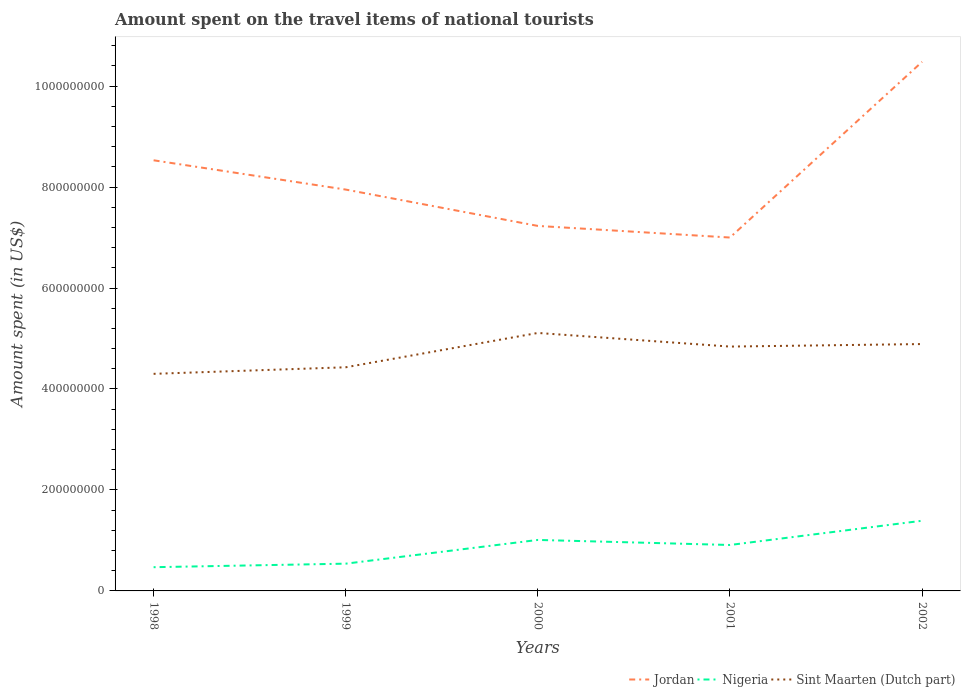Across all years, what is the maximum amount spent on the travel items of national tourists in Nigeria?
Your answer should be very brief. 4.70e+07. In which year was the amount spent on the travel items of national tourists in Sint Maarten (Dutch part) maximum?
Provide a succinct answer. 1998. What is the total amount spent on the travel items of national tourists in Jordan in the graph?
Your answer should be very brief. -2.53e+08. What is the difference between the highest and the second highest amount spent on the travel items of national tourists in Sint Maarten (Dutch part)?
Keep it short and to the point. 8.10e+07. How many lines are there?
Ensure brevity in your answer.  3. Are the values on the major ticks of Y-axis written in scientific E-notation?
Give a very brief answer. No. Does the graph contain grids?
Provide a succinct answer. No. Where does the legend appear in the graph?
Your answer should be compact. Bottom right. How many legend labels are there?
Your answer should be very brief. 3. How are the legend labels stacked?
Provide a succinct answer. Horizontal. What is the title of the graph?
Keep it short and to the point. Amount spent on the travel items of national tourists. Does "Central Europe" appear as one of the legend labels in the graph?
Keep it short and to the point. No. What is the label or title of the Y-axis?
Keep it short and to the point. Amount spent (in US$). What is the Amount spent (in US$) in Jordan in 1998?
Your answer should be very brief. 8.53e+08. What is the Amount spent (in US$) of Nigeria in 1998?
Provide a succinct answer. 4.70e+07. What is the Amount spent (in US$) of Sint Maarten (Dutch part) in 1998?
Provide a succinct answer. 4.30e+08. What is the Amount spent (in US$) of Jordan in 1999?
Provide a succinct answer. 7.95e+08. What is the Amount spent (in US$) in Nigeria in 1999?
Your response must be concise. 5.40e+07. What is the Amount spent (in US$) of Sint Maarten (Dutch part) in 1999?
Give a very brief answer. 4.43e+08. What is the Amount spent (in US$) of Jordan in 2000?
Make the answer very short. 7.23e+08. What is the Amount spent (in US$) of Nigeria in 2000?
Your answer should be compact. 1.01e+08. What is the Amount spent (in US$) of Sint Maarten (Dutch part) in 2000?
Make the answer very short. 5.11e+08. What is the Amount spent (in US$) in Jordan in 2001?
Provide a succinct answer. 7.00e+08. What is the Amount spent (in US$) of Nigeria in 2001?
Make the answer very short. 9.10e+07. What is the Amount spent (in US$) in Sint Maarten (Dutch part) in 2001?
Provide a succinct answer. 4.84e+08. What is the Amount spent (in US$) of Jordan in 2002?
Offer a terse response. 1.05e+09. What is the Amount spent (in US$) in Nigeria in 2002?
Offer a terse response. 1.39e+08. What is the Amount spent (in US$) of Sint Maarten (Dutch part) in 2002?
Keep it short and to the point. 4.89e+08. Across all years, what is the maximum Amount spent (in US$) in Jordan?
Make the answer very short. 1.05e+09. Across all years, what is the maximum Amount spent (in US$) in Nigeria?
Offer a terse response. 1.39e+08. Across all years, what is the maximum Amount spent (in US$) of Sint Maarten (Dutch part)?
Your answer should be compact. 5.11e+08. Across all years, what is the minimum Amount spent (in US$) in Jordan?
Ensure brevity in your answer.  7.00e+08. Across all years, what is the minimum Amount spent (in US$) of Nigeria?
Make the answer very short. 4.70e+07. Across all years, what is the minimum Amount spent (in US$) in Sint Maarten (Dutch part)?
Your answer should be very brief. 4.30e+08. What is the total Amount spent (in US$) in Jordan in the graph?
Provide a short and direct response. 4.12e+09. What is the total Amount spent (in US$) of Nigeria in the graph?
Offer a terse response. 4.32e+08. What is the total Amount spent (in US$) of Sint Maarten (Dutch part) in the graph?
Offer a very short reply. 2.36e+09. What is the difference between the Amount spent (in US$) of Jordan in 1998 and that in 1999?
Your response must be concise. 5.80e+07. What is the difference between the Amount spent (in US$) of Nigeria in 1998 and that in 1999?
Your answer should be very brief. -7.00e+06. What is the difference between the Amount spent (in US$) in Sint Maarten (Dutch part) in 1998 and that in 1999?
Provide a succinct answer. -1.30e+07. What is the difference between the Amount spent (in US$) of Jordan in 1998 and that in 2000?
Give a very brief answer. 1.30e+08. What is the difference between the Amount spent (in US$) in Nigeria in 1998 and that in 2000?
Your response must be concise. -5.40e+07. What is the difference between the Amount spent (in US$) in Sint Maarten (Dutch part) in 1998 and that in 2000?
Your answer should be very brief. -8.10e+07. What is the difference between the Amount spent (in US$) of Jordan in 1998 and that in 2001?
Make the answer very short. 1.53e+08. What is the difference between the Amount spent (in US$) of Nigeria in 1998 and that in 2001?
Provide a short and direct response. -4.40e+07. What is the difference between the Amount spent (in US$) of Sint Maarten (Dutch part) in 1998 and that in 2001?
Provide a succinct answer. -5.40e+07. What is the difference between the Amount spent (in US$) in Jordan in 1998 and that in 2002?
Offer a very short reply. -1.95e+08. What is the difference between the Amount spent (in US$) in Nigeria in 1998 and that in 2002?
Offer a terse response. -9.20e+07. What is the difference between the Amount spent (in US$) in Sint Maarten (Dutch part) in 1998 and that in 2002?
Provide a succinct answer. -5.90e+07. What is the difference between the Amount spent (in US$) in Jordan in 1999 and that in 2000?
Give a very brief answer. 7.20e+07. What is the difference between the Amount spent (in US$) in Nigeria in 1999 and that in 2000?
Keep it short and to the point. -4.70e+07. What is the difference between the Amount spent (in US$) of Sint Maarten (Dutch part) in 1999 and that in 2000?
Give a very brief answer. -6.80e+07. What is the difference between the Amount spent (in US$) in Jordan in 1999 and that in 2001?
Give a very brief answer. 9.50e+07. What is the difference between the Amount spent (in US$) of Nigeria in 1999 and that in 2001?
Give a very brief answer. -3.70e+07. What is the difference between the Amount spent (in US$) of Sint Maarten (Dutch part) in 1999 and that in 2001?
Keep it short and to the point. -4.10e+07. What is the difference between the Amount spent (in US$) in Jordan in 1999 and that in 2002?
Give a very brief answer. -2.53e+08. What is the difference between the Amount spent (in US$) in Nigeria in 1999 and that in 2002?
Make the answer very short. -8.50e+07. What is the difference between the Amount spent (in US$) in Sint Maarten (Dutch part) in 1999 and that in 2002?
Ensure brevity in your answer.  -4.60e+07. What is the difference between the Amount spent (in US$) in Jordan in 2000 and that in 2001?
Keep it short and to the point. 2.30e+07. What is the difference between the Amount spent (in US$) in Nigeria in 2000 and that in 2001?
Your answer should be compact. 1.00e+07. What is the difference between the Amount spent (in US$) of Sint Maarten (Dutch part) in 2000 and that in 2001?
Provide a succinct answer. 2.70e+07. What is the difference between the Amount spent (in US$) in Jordan in 2000 and that in 2002?
Offer a very short reply. -3.25e+08. What is the difference between the Amount spent (in US$) of Nigeria in 2000 and that in 2002?
Your answer should be compact. -3.80e+07. What is the difference between the Amount spent (in US$) of Sint Maarten (Dutch part) in 2000 and that in 2002?
Provide a short and direct response. 2.20e+07. What is the difference between the Amount spent (in US$) in Jordan in 2001 and that in 2002?
Your answer should be compact. -3.48e+08. What is the difference between the Amount spent (in US$) of Nigeria in 2001 and that in 2002?
Ensure brevity in your answer.  -4.80e+07. What is the difference between the Amount spent (in US$) of Sint Maarten (Dutch part) in 2001 and that in 2002?
Offer a terse response. -5.00e+06. What is the difference between the Amount spent (in US$) of Jordan in 1998 and the Amount spent (in US$) of Nigeria in 1999?
Your response must be concise. 7.99e+08. What is the difference between the Amount spent (in US$) in Jordan in 1998 and the Amount spent (in US$) in Sint Maarten (Dutch part) in 1999?
Provide a short and direct response. 4.10e+08. What is the difference between the Amount spent (in US$) of Nigeria in 1998 and the Amount spent (in US$) of Sint Maarten (Dutch part) in 1999?
Your answer should be compact. -3.96e+08. What is the difference between the Amount spent (in US$) of Jordan in 1998 and the Amount spent (in US$) of Nigeria in 2000?
Keep it short and to the point. 7.52e+08. What is the difference between the Amount spent (in US$) in Jordan in 1998 and the Amount spent (in US$) in Sint Maarten (Dutch part) in 2000?
Your response must be concise. 3.42e+08. What is the difference between the Amount spent (in US$) of Nigeria in 1998 and the Amount spent (in US$) of Sint Maarten (Dutch part) in 2000?
Keep it short and to the point. -4.64e+08. What is the difference between the Amount spent (in US$) in Jordan in 1998 and the Amount spent (in US$) in Nigeria in 2001?
Keep it short and to the point. 7.62e+08. What is the difference between the Amount spent (in US$) in Jordan in 1998 and the Amount spent (in US$) in Sint Maarten (Dutch part) in 2001?
Give a very brief answer. 3.69e+08. What is the difference between the Amount spent (in US$) in Nigeria in 1998 and the Amount spent (in US$) in Sint Maarten (Dutch part) in 2001?
Your response must be concise. -4.37e+08. What is the difference between the Amount spent (in US$) in Jordan in 1998 and the Amount spent (in US$) in Nigeria in 2002?
Offer a very short reply. 7.14e+08. What is the difference between the Amount spent (in US$) in Jordan in 1998 and the Amount spent (in US$) in Sint Maarten (Dutch part) in 2002?
Make the answer very short. 3.64e+08. What is the difference between the Amount spent (in US$) of Nigeria in 1998 and the Amount spent (in US$) of Sint Maarten (Dutch part) in 2002?
Give a very brief answer. -4.42e+08. What is the difference between the Amount spent (in US$) of Jordan in 1999 and the Amount spent (in US$) of Nigeria in 2000?
Make the answer very short. 6.94e+08. What is the difference between the Amount spent (in US$) in Jordan in 1999 and the Amount spent (in US$) in Sint Maarten (Dutch part) in 2000?
Your answer should be compact. 2.84e+08. What is the difference between the Amount spent (in US$) in Nigeria in 1999 and the Amount spent (in US$) in Sint Maarten (Dutch part) in 2000?
Offer a very short reply. -4.57e+08. What is the difference between the Amount spent (in US$) in Jordan in 1999 and the Amount spent (in US$) in Nigeria in 2001?
Provide a succinct answer. 7.04e+08. What is the difference between the Amount spent (in US$) in Jordan in 1999 and the Amount spent (in US$) in Sint Maarten (Dutch part) in 2001?
Give a very brief answer. 3.11e+08. What is the difference between the Amount spent (in US$) in Nigeria in 1999 and the Amount spent (in US$) in Sint Maarten (Dutch part) in 2001?
Keep it short and to the point. -4.30e+08. What is the difference between the Amount spent (in US$) in Jordan in 1999 and the Amount spent (in US$) in Nigeria in 2002?
Make the answer very short. 6.56e+08. What is the difference between the Amount spent (in US$) of Jordan in 1999 and the Amount spent (in US$) of Sint Maarten (Dutch part) in 2002?
Keep it short and to the point. 3.06e+08. What is the difference between the Amount spent (in US$) of Nigeria in 1999 and the Amount spent (in US$) of Sint Maarten (Dutch part) in 2002?
Ensure brevity in your answer.  -4.35e+08. What is the difference between the Amount spent (in US$) of Jordan in 2000 and the Amount spent (in US$) of Nigeria in 2001?
Provide a short and direct response. 6.32e+08. What is the difference between the Amount spent (in US$) of Jordan in 2000 and the Amount spent (in US$) of Sint Maarten (Dutch part) in 2001?
Your response must be concise. 2.39e+08. What is the difference between the Amount spent (in US$) of Nigeria in 2000 and the Amount spent (in US$) of Sint Maarten (Dutch part) in 2001?
Offer a very short reply. -3.83e+08. What is the difference between the Amount spent (in US$) in Jordan in 2000 and the Amount spent (in US$) in Nigeria in 2002?
Provide a short and direct response. 5.84e+08. What is the difference between the Amount spent (in US$) in Jordan in 2000 and the Amount spent (in US$) in Sint Maarten (Dutch part) in 2002?
Make the answer very short. 2.34e+08. What is the difference between the Amount spent (in US$) of Nigeria in 2000 and the Amount spent (in US$) of Sint Maarten (Dutch part) in 2002?
Provide a short and direct response. -3.88e+08. What is the difference between the Amount spent (in US$) in Jordan in 2001 and the Amount spent (in US$) in Nigeria in 2002?
Offer a very short reply. 5.61e+08. What is the difference between the Amount spent (in US$) in Jordan in 2001 and the Amount spent (in US$) in Sint Maarten (Dutch part) in 2002?
Make the answer very short. 2.11e+08. What is the difference between the Amount spent (in US$) of Nigeria in 2001 and the Amount spent (in US$) of Sint Maarten (Dutch part) in 2002?
Provide a short and direct response. -3.98e+08. What is the average Amount spent (in US$) of Jordan per year?
Give a very brief answer. 8.24e+08. What is the average Amount spent (in US$) of Nigeria per year?
Provide a succinct answer. 8.64e+07. What is the average Amount spent (in US$) of Sint Maarten (Dutch part) per year?
Provide a succinct answer. 4.71e+08. In the year 1998, what is the difference between the Amount spent (in US$) of Jordan and Amount spent (in US$) of Nigeria?
Your response must be concise. 8.06e+08. In the year 1998, what is the difference between the Amount spent (in US$) of Jordan and Amount spent (in US$) of Sint Maarten (Dutch part)?
Your response must be concise. 4.23e+08. In the year 1998, what is the difference between the Amount spent (in US$) of Nigeria and Amount spent (in US$) of Sint Maarten (Dutch part)?
Offer a very short reply. -3.83e+08. In the year 1999, what is the difference between the Amount spent (in US$) in Jordan and Amount spent (in US$) in Nigeria?
Ensure brevity in your answer.  7.41e+08. In the year 1999, what is the difference between the Amount spent (in US$) in Jordan and Amount spent (in US$) in Sint Maarten (Dutch part)?
Your response must be concise. 3.52e+08. In the year 1999, what is the difference between the Amount spent (in US$) in Nigeria and Amount spent (in US$) in Sint Maarten (Dutch part)?
Provide a short and direct response. -3.89e+08. In the year 2000, what is the difference between the Amount spent (in US$) of Jordan and Amount spent (in US$) of Nigeria?
Keep it short and to the point. 6.22e+08. In the year 2000, what is the difference between the Amount spent (in US$) in Jordan and Amount spent (in US$) in Sint Maarten (Dutch part)?
Keep it short and to the point. 2.12e+08. In the year 2000, what is the difference between the Amount spent (in US$) in Nigeria and Amount spent (in US$) in Sint Maarten (Dutch part)?
Ensure brevity in your answer.  -4.10e+08. In the year 2001, what is the difference between the Amount spent (in US$) of Jordan and Amount spent (in US$) of Nigeria?
Offer a very short reply. 6.09e+08. In the year 2001, what is the difference between the Amount spent (in US$) in Jordan and Amount spent (in US$) in Sint Maarten (Dutch part)?
Offer a very short reply. 2.16e+08. In the year 2001, what is the difference between the Amount spent (in US$) of Nigeria and Amount spent (in US$) of Sint Maarten (Dutch part)?
Your response must be concise. -3.93e+08. In the year 2002, what is the difference between the Amount spent (in US$) in Jordan and Amount spent (in US$) in Nigeria?
Your response must be concise. 9.09e+08. In the year 2002, what is the difference between the Amount spent (in US$) in Jordan and Amount spent (in US$) in Sint Maarten (Dutch part)?
Keep it short and to the point. 5.59e+08. In the year 2002, what is the difference between the Amount spent (in US$) of Nigeria and Amount spent (in US$) of Sint Maarten (Dutch part)?
Your answer should be very brief. -3.50e+08. What is the ratio of the Amount spent (in US$) in Jordan in 1998 to that in 1999?
Your answer should be compact. 1.07. What is the ratio of the Amount spent (in US$) of Nigeria in 1998 to that in 1999?
Make the answer very short. 0.87. What is the ratio of the Amount spent (in US$) of Sint Maarten (Dutch part) in 1998 to that in 1999?
Offer a very short reply. 0.97. What is the ratio of the Amount spent (in US$) in Jordan in 1998 to that in 2000?
Offer a very short reply. 1.18. What is the ratio of the Amount spent (in US$) in Nigeria in 1998 to that in 2000?
Your response must be concise. 0.47. What is the ratio of the Amount spent (in US$) of Sint Maarten (Dutch part) in 1998 to that in 2000?
Offer a very short reply. 0.84. What is the ratio of the Amount spent (in US$) of Jordan in 1998 to that in 2001?
Offer a very short reply. 1.22. What is the ratio of the Amount spent (in US$) in Nigeria in 1998 to that in 2001?
Provide a succinct answer. 0.52. What is the ratio of the Amount spent (in US$) in Sint Maarten (Dutch part) in 1998 to that in 2001?
Your response must be concise. 0.89. What is the ratio of the Amount spent (in US$) in Jordan in 1998 to that in 2002?
Make the answer very short. 0.81. What is the ratio of the Amount spent (in US$) of Nigeria in 1998 to that in 2002?
Ensure brevity in your answer.  0.34. What is the ratio of the Amount spent (in US$) in Sint Maarten (Dutch part) in 1998 to that in 2002?
Provide a succinct answer. 0.88. What is the ratio of the Amount spent (in US$) in Jordan in 1999 to that in 2000?
Make the answer very short. 1.1. What is the ratio of the Amount spent (in US$) in Nigeria in 1999 to that in 2000?
Offer a very short reply. 0.53. What is the ratio of the Amount spent (in US$) of Sint Maarten (Dutch part) in 1999 to that in 2000?
Your answer should be very brief. 0.87. What is the ratio of the Amount spent (in US$) of Jordan in 1999 to that in 2001?
Provide a short and direct response. 1.14. What is the ratio of the Amount spent (in US$) of Nigeria in 1999 to that in 2001?
Keep it short and to the point. 0.59. What is the ratio of the Amount spent (in US$) of Sint Maarten (Dutch part) in 1999 to that in 2001?
Offer a very short reply. 0.92. What is the ratio of the Amount spent (in US$) of Jordan in 1999 to that in 2002?
Make the answer very short. 0.76. What is the ratio of the Amount spent (in US$) in Nigeria in 1999 to that in 2002?
Your response must be concise. 0.39. What is the ratio of the Amount spent (in US$) in Sint Maarten (Dutch part) in 1999 to that in 2002?
Provide a succinct answer. 0.91. What is the ratio of the Amount spent (in US$) of Jordan in 2000 to that in 2001?
Provide a short and direct response. 1.03. What is the ratio of the Amount spent (in US$) of Nigeria in 2000 to that in 2001?
Your response must be concise. 1.11. What is the ratio of the Amount spent (in US$) in Sint Maarten (Dutch part) in 2000 to that in 2001?
Ensure brevity in your answer.  1.06. What is the ratio of the Amount spent (in US$) of Jordan in 2000 to that in 2002?
Provide a succinct answer. 0.69. What is the ratio of the Amount spent (in US$) in Nigeria in 2000 to that in 2002?
Make the answer very short. 0.73. What is the ratio of the Amount spent (in US$) in Sint Maarten (Dutch part) in 2000 to that in 2002?
Your answer should be compact. 1.04. What is the ratio of the Amount spent (in US$) in Jordan in 2001 to that in 2002?
Provide a succinct answer. 0.67. What is the ratio of the Amount spent (in US$) of Nigeria in 2001 to that in 2002?
Ensure brevity in your answer.  0.65. What is the difference between the highest and the second highest Amount spent (in US$) of Jordan?
Your answer should be very brief. 1.95e+08. What is the difference between the highest and the second highest Amount spent (in US$) of Nigeria?
Your answer should be very brief. 3.80e+07. What is the difference between the highest and the second highest Amount spent (in US$) in Sint Maarten (Dutch part)?
Offer a terse response. 2.20e+07. What is the difference between the highest and the lowest Amount spent (in US$) of Jordan?
Keep it short and to the point. 3.48e+08. What is the difference between the highest and the lowest Amount spent (in US$) in Nigeria?
Offer a terse response. 9.20e+07. What is the difference between the highest and the lowest Amount spent (in US$) in Sint Maarten (Dutch part)?
Give a very brief answer. 8.10e+07. 